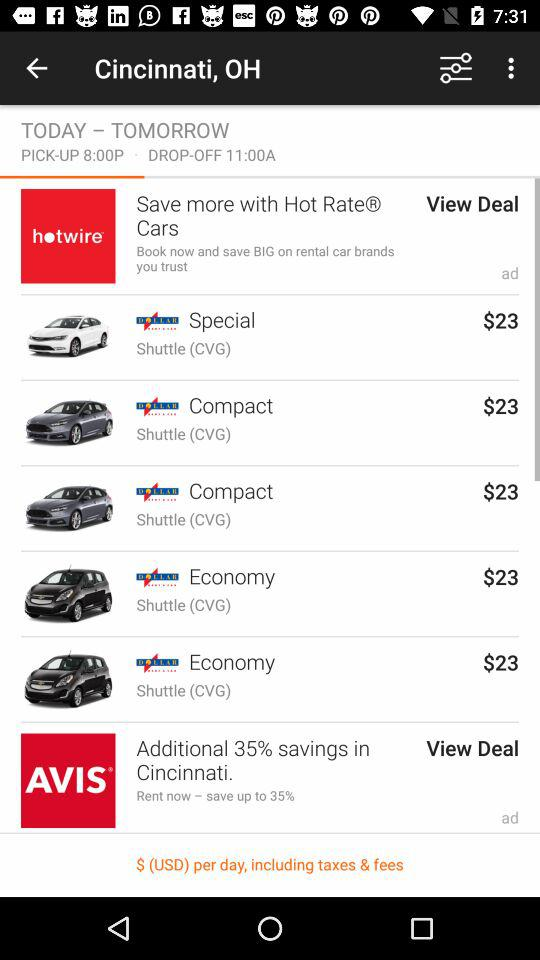What is the pick-up time? The pick-up time is 8:00 PM. 